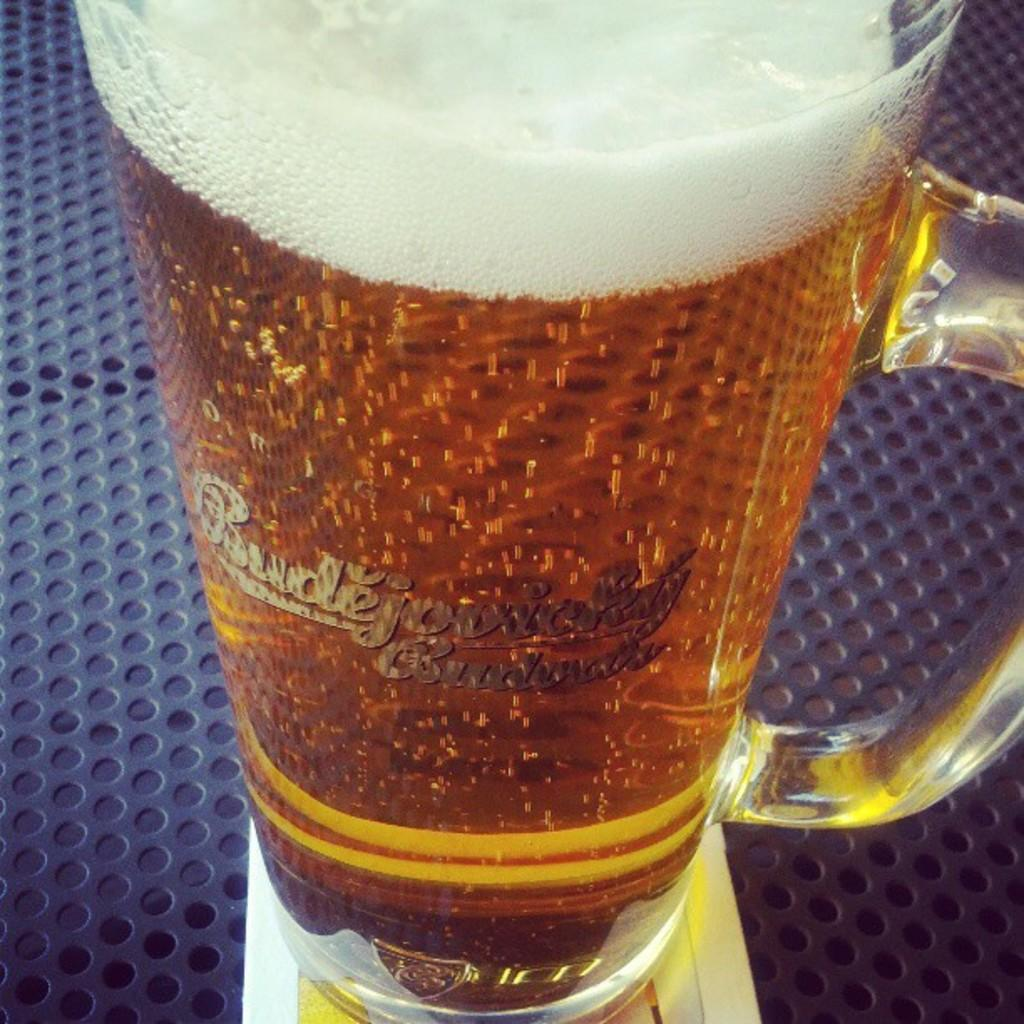What is contained in the glass that is visible in the image? There is a glass with liquid in the image. What is the glass placed on in the image? The glass is placed on an object. What color is the white-colored object in the image? The white-colored object is white. Is there a plastic swing visible in the image? No, there is no plastic swing present in the image. What type of event is taking place in the image? There is no event depicted in the image; it only shows a glass with liquid, an object, and a white-colored object. 